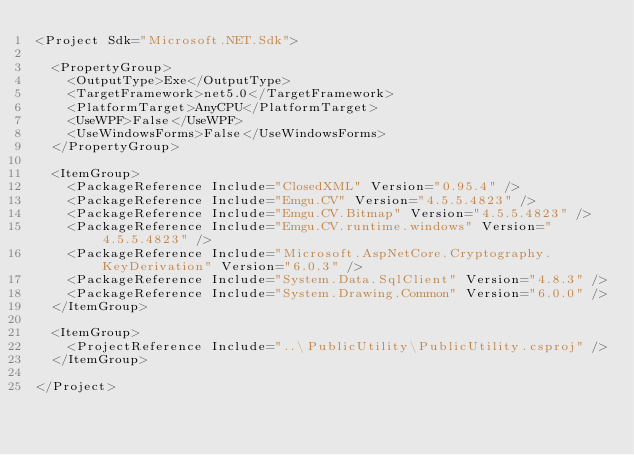<code> <loc_0><loc_0><loc_500><loc_500><_XML_><Project Sdk="Microsoft.NET.Sdk">

  <PropertyGroup>
    <OutputType>Exe</OutputType>
    <TargetFramework>net5.0</TargetFramework>
    <PlatformTarget>AnyCPU</PlatformTarget>
    <UseWPF>False</UseWPF>
    <UseWindowsForms>False</UseWindowsForms>
  </PropertyGroup>

  <ItemGroup>
    <PackageReference Include="ClosedXML" Version="0.95.4" />
    <PackageReference Include="Emgu.CV" Version="4.5.5.4823" />
    <PackageReference Include="Emgu.CV.Bitmap" Version="4.5.5.4823" />
    <PackageReference Include="Emgu.CV.runtime.windows" Version="4.5.5.4823" />
    <PackageReference Include="Microsoft.AspNetCore.Cryptography.KeyDerivation" Version="6.0.3" />
    <PackageReference Include="System.Data.SqlClient" Version="4.8.3" />
    <PackageReference Include="System.Drawing.Common" Version="6.0.0" />
  </ItemGroup>

  <ItemGroup>
    <ProjectReference Include="..\PublicUtility\PublicUtility.csproj" />
  </ItemGroup>

</Project>
</code> 